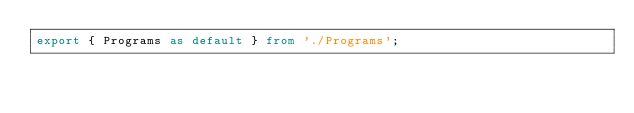Convert code to text. <code><loc_0><loc_0><loc_500><loc_500><_TypeScript_>export { Programs as default } from './Programs';
</code> 